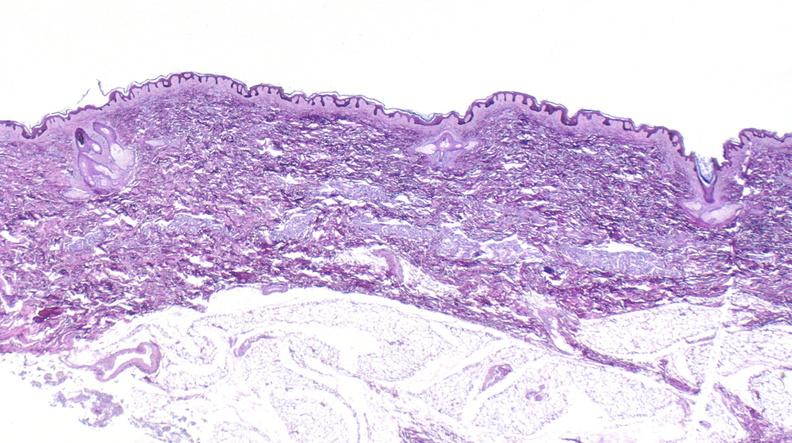does this image show scleroderma?
Answer the question using a single word or phrase. Yes 